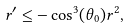<formula> <loc_0><loc_0><loc_500><loc_500>r ^ { \prime } \leq - \cos ^ { 3 } ( \theta _ { 0 } ) r ^ { 2 } ,</formula> 